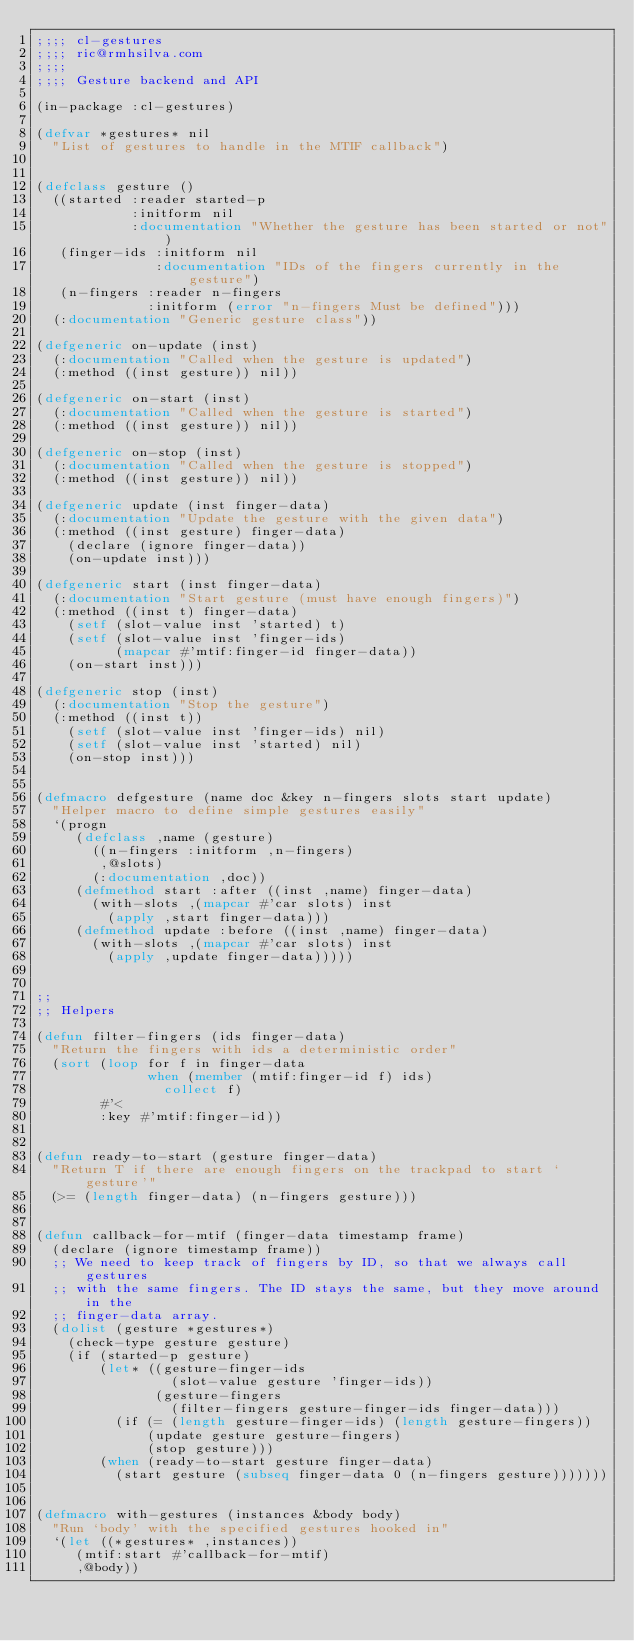Convert code to text. <code><loc_0><loc_0><loc_500><loc_500><_Lisp_>;;;; cl-gestures
;;;; ric@rmhsilva.com
;;;;
;;;; Gesture backend and API

(in-package :cl-gestures)

(defvar *gestures* nil
  "List of gestures to handle in the MTIF callback")


(defclass gesture ()
  ((started :reader started-p
            :initform nil
            :documentation "Whether the gesture has been started or not")
   (finger-ids :initform nil
               :documentation "IDs of the fingers currently in the gesture")
   (n-fingers :reader n-fingers
              :initform (error "n-fingers Must be defined")))
  (:documentation "Generic gesture class"))

(defgeneric on-update (inst)
  (:documentation "Called when the gesture is updated")
  (:method ((inst gesture)) nil))

(defgeneric on-start (inst)
  (:documentation "Called when the gesture is started")
  (:method ((inst gesture)) nil))

(defgeneric on-stop (inst)
  (:documentation "Called when the gesture is stopped")
  (:method ((inst gesture)) nil))

(defgeneric update (inst finger-data)
  (:documentation "Update the gesture with the given data")
  (:method ((inst gesture) finger-data)
    (declare (ignore finger-data))
    (on-update inst)))

(defgeneric start (inst finger-data)
  (:documentation "Start gesture (must have enough fingers)")
  (:method ((inst t) finger-data)
    (setf (slot-value inst 'started) t)
    (setf (slot-value inst 'finger-ids)
          (mapcar #'mtif:finger-id finger-data))
    (on-start inst)))

(defgeneric stop (inst)
  (:documentation "Stop the gesture")
  (:method ((inst t))
    (setf (slot-value inst 'finger-ids) nil)
    (setf (slot-value inst 'started) nil)
    (on-stop inst)))


(defmacro defgesture (name doc &key n-fingers slots start update)
  "Helper macro to define simple gestures easily"
  `(progn
     (defclass ,name (gesture)
       ((n-fingers :initform ,n-fingers)
        ,@slots)
       (:documentation ,doc))
     (defmethod start :after ((inst ,name) finger-data)
       (with-slots ,(mapcar #'car slots) inst
         (apply ,start finger-data)))
     (defmethod update :before ((inst ,name) finger-data)
       (with-slots ,(mapcar #'car slots) inst
         (apply ,update finger-data)))))


;;
;; Helpers

(defun filter-fingers (ids finger-data)
  "Return the fingers with ids a deterministic order"
  (sort (loop for f in finger-data
              when (member (mtif:finger-id f) ids)
                collect f)
        #'<
        :key #'mtif:finger-id))


(defun ready-to-start (gesture finger-data)
  "Return T if there are enough fingers on the trackpad to start `gesture'"
  (>= (length finger-data) (n-fingers gesture)))


(defun callback-for-mtif (finger-data timestamp frame)
  (declare (ignore timestamp frame))
  ;; We need to keep track of fingers by ID, so that we always call gestures
  ;; with the same fingers. The ID stays the same, but they move around in the
  ;; finger-data array.
  (dolist (gesture *gestures*)
    (check-type gesture gesture)
    (if (started-p gesture)
        (let* ((gesture-finger-ids
                 (slot-value gesture 'finger-ids))
               (gesture-fingers
                 (filter-fingers gesture-finger-ids finger-data)))
          (if (= (length gesture-finger-ids) (length gesture-fingers))
              (update gesture gesture-fingers)
              (stop gesture)))
        (when (ready-to-start gesture finger-data)
          (start gesture (subseq finger-data 0 (n-fingers gesture)))))))


(defmacro with-gestures (instances &body body)
  "Run `body' with the specified gestures hooked in"
  `(let ((*gestures* ,instances))
     (mtif:start #'callback-for-mtif)
     ,@body))
</code> 